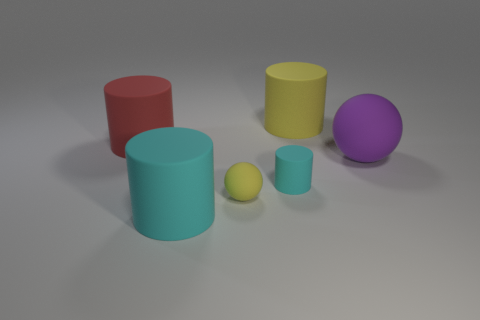What number of other things are there of the same size as the yellow sphere?
Your answer should be very brief. 1. What is the size of the rubber cylinder that is the same color as the small sphere?
Keep it short and to the point. Large. What number of cylinders are either gray matte objects or rubber things?
Your answer should be very brief. 4. Does the yellow matte thing that is behind the red matte thing have the same shape as the red rubber object?
Ensure brevity in your answer.  Yes. Are there more objects in front of the large red cylinder than large red metallic blocks?
Give a very brief answer. Yes. There is a rubber sphere that is the same size as the red object; what is its color?
Keep it short and to the point. Purple. What number of objects are either cylinders left of the yellow matte ball or yellow matte objects?
Your answer should be compact. 4. What is the shape of the rubber object that is the same color as the small rubber ball?
Offer a terse response. Cylinder. Are there any tiny spheres made of the same material as the small yellow thing?
Give a very brief answer. No. There is a yellow thing in front of the big purple thing; is there a yellow ball that is behind it?
Provide a succinct answer. No. 